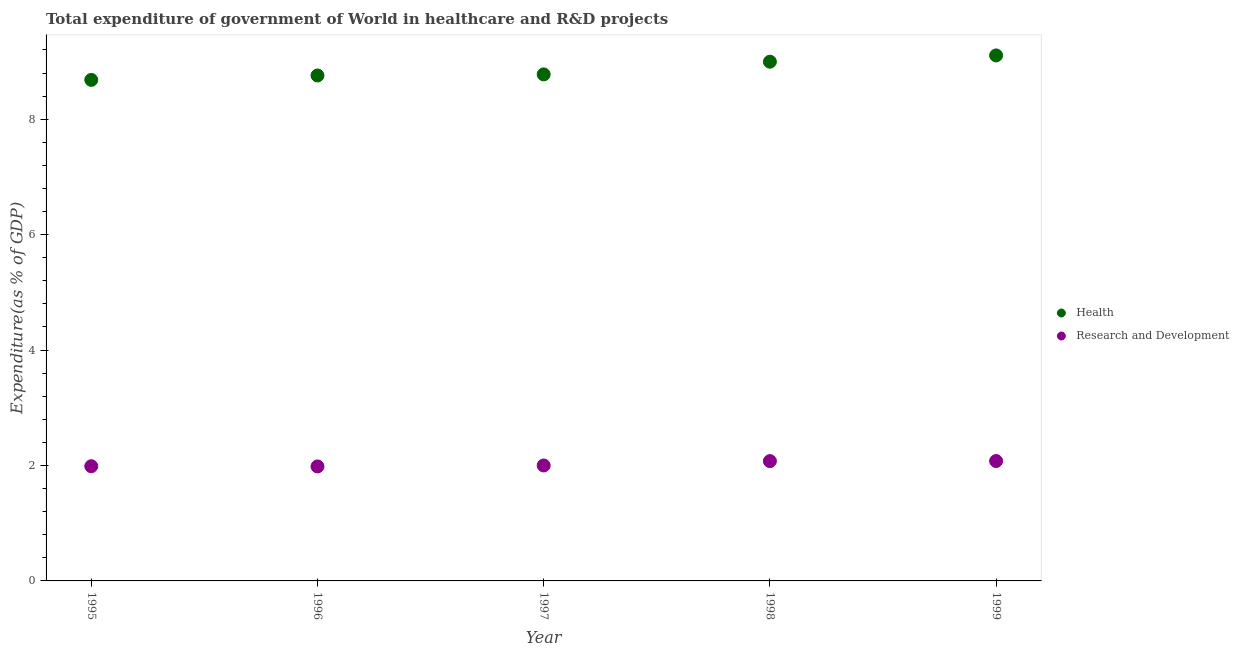What is the expenditure in healthcare in 1998?
Provide a short and direct response. 9. Across all years, what is the maximum expenditure in healthcare?
Your answer should be compact. 9.11. Across all years, what is the minimum expenditure in healthcare?
Provide a succinct answer. 8.68. In which year was the expenditure in healthcare maximum?
Offer a terse response. 1999. In which year was the expenditure in r&d minimum?
Give a very brief answer. 1996. What is the total expenditure in r&d in the graph?
Offer a terse response. 10.13. What is the difference between the expenditure in r&d in 1997 and that in 1999?
Ensure brevity in your answer.  -0.08. What is the difference between the expenditure in r&d in 1997 and the expenditure in healthcare in 1999?
Offer a terse response. -7.1. What is the average expenditure in r&d per year?
Make the answer very short. 2.03. In the year 1995, what is the difference between the expenditure in r&d and expenditure in healthcare?
Make the answer very short. -6.69. What is the ratio of the expenditure in r&d in 1997 to that in 1999?
Offer a very short reply. 0.96. Is the difference between the expenditure in r&d in 1998 and 1999 greater than the difference between the expenditure in healthcare in 1998 and 1999?
Keep it short and to the point. Yes. What is the difference between the highest and the second highest expenditure in r&d?
Keep it short and to the point. 0. What is the difference between the highest and the lowest expenditure in healthcare?
Provide a short and direct response. 0.42. Is the sum of the expenditure in healthcare in 1997 and 1999 greater than the maximum expenditure in r&d across all years?
Your response must be concise. Yes. Is the expenditure in r&d strictly greater than the expenditure in healthcare over the years?
Your answer should be compact. No. How many dotlines are there?
Offer a terse response. 2. What is the difference between two consecutive major ticks on the Y-axis?
Your answer should be compact. 2. Does the graph contain grids?
Provide a succinct answer. No. Where does the legend appear in the graph?
Make the answer very short. Center right. How many legend labels are there?
Offer a very short reply. 2. How are the legend labels stacked?
Provide a short and direct response. Vertical. What is the title of the graph?
Provide a succinct answer. Total expenditure of government of World in healthcare and R&D projects. What is the label or title of the X-axis?
Make the answer very short. Year. What is the label or title of the Y-axis?
Offer a terse response. Expenditure(as % of GDP). What is the Expenditure(as % of GDP) of Health in 1995?
Your response must be concise. 8.68. What is the Expenditure(as % of GDP) in Research and Development in 1995?
Provide a succinct answer. 1.99. What is the Expenditure(as % of GDP) of Health in 1996?
Make the answer very short. 8.76. What is the Expenditure(as % of GDP) in Research and Development in 1996?
Make the answer very short. 1.98. What is the Expenditure(as % of GDP) of Health in 1997?
Offer a very short reply. 8.78. What is the Expenditure(as % of GDP) of Research and Development in 1997?
Offer a terse response. 2. What is the Expenditure(as % of GDP) in Health in 1998?
Offer a terse response. 9. What is the Expenditure(as % of GDP) in Research and Development in 1998?
Ensure brevity in your answer.  2.08. What is the Expenditure(as % of GDP) of Health in 1999?
Your response must be concise. 9.11. What is the Expenditure(as % of GDP) of Research and Development in 1999?
Make the answer very short. 2.08. Across all years, what is the maximum Expenditure(as % of GDP) of Health?
Offer a very short reply. 9.11. Across all years, what is the maximum Expenditure(as % of GDP) of Research and Development?
Your answer should be very brief. 2.08. Across all years, what is the minimum Expenditure(as % of GDP) in Health?
Your answer should be very brief. 8.68. Across all years, what is the minimum Expenditure(as % of GDP) of Research and Development?
Ensure brevity in your answer.  1.98. What is the total Expenditure(as % of GDP) of Health in the graph?
Provide a short and direct response. 44.32. What is the total Expenditure(as % of GDP) in Research and Development in the graph?
Ensure brevity in your answer.  10.13. What is the difference between the Expenditure(as % of GDP) of Health in 1995 and that in 1996?
Keep it short and to the point. -0.08. What is the difference between the Expenditure(as % of GDP) of Research and Development in 1995 and that in 1996?
Offer a very short reply. 0. What is the difference between the Expenditure(as % of GDP) of Health in 1995 and that in 1997?
Make the answer very short. -0.1. What is the difference between the Expenditure(as % of GDP) of Research and Development in 1995 and that in 1997?
Offer a very short reply. -0.01. What is the difference between the Expenditure(as % of GDP) of Health in 1995 and that in 1998?
Make the answer very short. -0.32. What is the difference between the Expenditure(as % of GDP) in Research and Development in 1995 and that in 1998?
Make the answer very short. -0.09. What is the difference between the Expenditure(as % of GDP) of Health in 1995 and that in 1999?
Ensure brevity in your answer.  -0.42. What is the difference between the Expenditure(as % of GDP) in Research and Development in 1995 and that in 1999?
Your answer should be compact. -0.09. What is the difference between the Expenditure(as % of GDP) of Health in 1996 and that in 1997?
Give a very brief answer. -0.02. What is the difference between the Expenditure(as % of GDP) in Research and Development in 1996 and that in 1997?
Provide a short and direct response. -0.02. What is the difference between the Expenditure(as % of GDP) of Health in 1996 and that in 1998?
Make the answer very short. -0.24. What is the difference between the Expenditure(as % of GDP) in Research and Development in 1996 and that in 1998?
Your response must be concise. -0.09. What is the difference between the Expenditure(as % of GDP) in Health in 1996 and that in 1999?
Provide a succinct answer. -0.35. What is the difference between the Expenditure(as % of GDP) in Research and Development in 1996 and that in 1999?
Your answer should be very brief. -0.09. What is the difference between the Expenditure(as % of GDP) of Health in 1997 and that in 1998?
Your answer should be very brief. -0.22. What is the difference between the Expenditure(as % of GDP) in Research and Development in 1997 and that in 1998?
Your answer should be very brief. -0.08. What is the difference between the Expenditure(as % of GDP) of Health in 1997 and that in 1999?
Keep it short and to the point. -0.33. What is the difference between the Expenditure(as % of GDP) of Research and Development in 1997 and that in 1999?
Provide a short and direct response. -0.08. What is the difference between the Expenditure(as % of GDP) in Health in 1998 and that in 1999?
Your response must be concise. -0.11. What is the difference between the Expenditure(as % of GDP) in Research and Development in 1998 and that in 1999?
Ensure brevity in your answer.  -0. What is the difference between the Expenditure(as % of GDP) in Health in 1995 and the Expenditure(as % of GDP) in Research and Development in 1996?
Give a very brief answer. 6.7. What is the difference between the Expenditure(as % of GDP) in Health in 1995 and the Expenditure(as % of GDP) in Research and Development in 1997?
Your answer should be compact. 6.68. What is the difference between the Expenditure(as % of GDP) in Health in 1995 and the Expenditure(as % of GDP) in Research and Development in 1998?
Your answer should be compact. 6.61. What is the difference between the Expenditure(as % of GDP) in Health in 1995 and the Expenditure(as % of GDP) in Research and Development in 1999?
Your answer should be compact. 6.6. What is the difference between the Expenditure(as % of GDP) in Health in 1996 and the Expenditure(as % of GDP) in Research and Development in 1997?
Your answer should be very brief. 6.76. What is the difference between the Expenditure(as % of GDP) in Health in 1996 and the Expenditure(as % of GDP) in Research and Development in 1998?
Provide a succinct answer. 6.68. What is the difference between the Expenditure(as % of GDP) in Health in 1996 and the Expenditure(as % of GDP) in Research and Development in 1999?
Provide a succinct answer. 6.68. What is the difference between the Expenditure(as % of GDP) of Health in 1997 and the Expenditure(as % of GDP) of Research and Development in 1998?
Make the answer very short. 6.7. What is the difference between the Expenditure(as % of GDP) of Health in 1997 and the Expenditure(as % of GDP) of Research and Development in 1999?
Your response must be concise. 6.7. What is the difference between the Expenditure(as % of GDP) in Health in 1998 and the Expenditure(as % of GDP) in Research and Development in 1999?
Keep it short and to the point. 6.92. What is the average Expenditure(as % of GDP) in Health per year?
Provide a succinct answer. 8.86. What is the average Expenditure(as % of GDP) of Research and Development per year?
Your answer should be very brief. 2.03. In the year 1995, what is the difference between the Expenditure(as % of GDP) in Health and Expenditure(as % of GDP) in Research and Development?
Give a very brief answer. 6.69. In the year 1996, what is the difference between the Expenditure(as % of GDP) of Health and Expenditure(as % of GDP) of Research and Development?
Offer a very short reply. 6.77. In the year 1997, what is the difference between the Expenditure(as % of GDP) of Health and Expenditure(as % of GDP) of Research and Development?
Make the answer very short. 6.78. In the year 1998, what is the difference between the Expenditure(as % of GDP) in Health and Expenditure(as % of GDP) in Research and Development?
Offer a terse response. 6.92. In the year 1999, what is the difference between the Expenditure(as % of GDP) of Health and Expenditure(as % of GDP) of Research and Development?
Provide a short and direct response. 7.03. What is the ratio of the Expenditure(as % of GDP) in Health in 1995 to that in 1996?
Keep it short and to the point. 0.99. What is the ratio of the Expenditure(as % of GDP) of Research and Development in 1995 to that in 1996?
Provide a short and direct response. 1. What is the ratio of the Expenditure(as % of GDP) of Health in 1995 to that in 1997?
Your response must be concise. 0.99. What is the ratio of the Expenditure(as % of GDP) of Research and Development in 1995 to that in 1997?
Make the answer very short. 0.99. What is the ratio of the Expenditure(as % of GDP) of Research and Development in 1995 to that in 1998?
Your answer should be compact. 0.96. What is the ratio of the Expenditure(as % of GDP) of Health in 1995 to that in 1999?
Your response must be concise. 0.95. What is the ratio of the Expenditure(as % of GDP) in Research and Development in 1995 to that in 1999?
Your response must be concise. 0.96. What is the ratio of the Expenditure(as % of GDP) in Health in 1996 to that in 1997?
Your answer should be compact. 1. What is the ratio of the Expenditure(as % of GDP) of Research and Development in 1996 to that in 1997?
Ensure brevity in your answer.  0.99. What is the ratio of the Expenditure(as % of GDP) of Health in 1996 to that in 1998?
Your answer should be very brief. 0.97. What is the ratio of the Expenditure(as % of GDP) of Research and Development in 1996 to that in 1998?
Give a very brief answer. 0.96. What is the ratio of the Expenditure(as % of GDP) of Health in 1996 to that in 1999?
Offer a terse response. 0.96. What is the ratio of the Expenditure(as % of GDP) in Research and Development in 1996 to that in 1999?
Your answer should be compact. 0.95. What is the ratio of the Expenditure(as % of GDP) of Health in 1997 to that in 1998?
Provide a succinct answer. 0.98. What is the ratio of the Expenditure(as % of GDP) of Research and Development in 1997 to that in 1998?
Provide a short and direct response. 0.96. What is the ratio of the Expenditure(as % of GDP) of Health in 1997 to that in 1999?
Your answer should be very brief. 0.96. What is the ratio of the Expenditure(as % of GDP) in Research and Development in 1997 to that in 1999?
Offer a very short reply. 0.96. What is the ratio of the Expenditure(as % of GDP) in Health in 1998 to that in 1999?
Give a very brief answer. 0.99. What is the difference between the highest and the second highest Expenditure(as % of GDP) of Health?
Offer a very short reply. 0.11. What is the difference between the highest and the second highest Expenditure(as % of GDP) in Research and Development?
Your answer should be compact. 0. What is the difference between the highest and the lowest Expenditure(as % of GDP) in Health?
Provide a succinct answer. 0.42. What is the difference between the highest and the lowest Expenditure(as % of GDP) in Research and Development?
Provide a short and direct response. 0.09. 